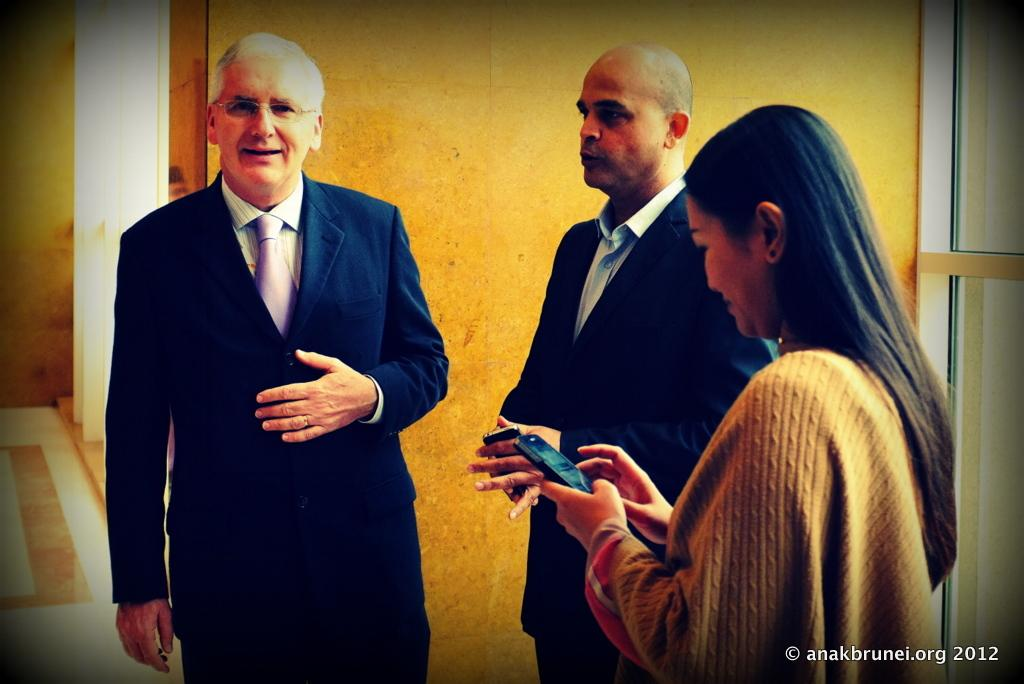How many people are present in the image? There are three people standing in the image. Can you describe the facial expression of the person on the left? The person on the left is smiling. What is the woman on the left doing in the image? The woman on the left is operating a smartphone. What type of bear can be seen accompanying the people on their voyage in the image? There is no bear or voyage present in the image; it features three people standing together. How many mice are visible in the image? There are no mice present in the image. 